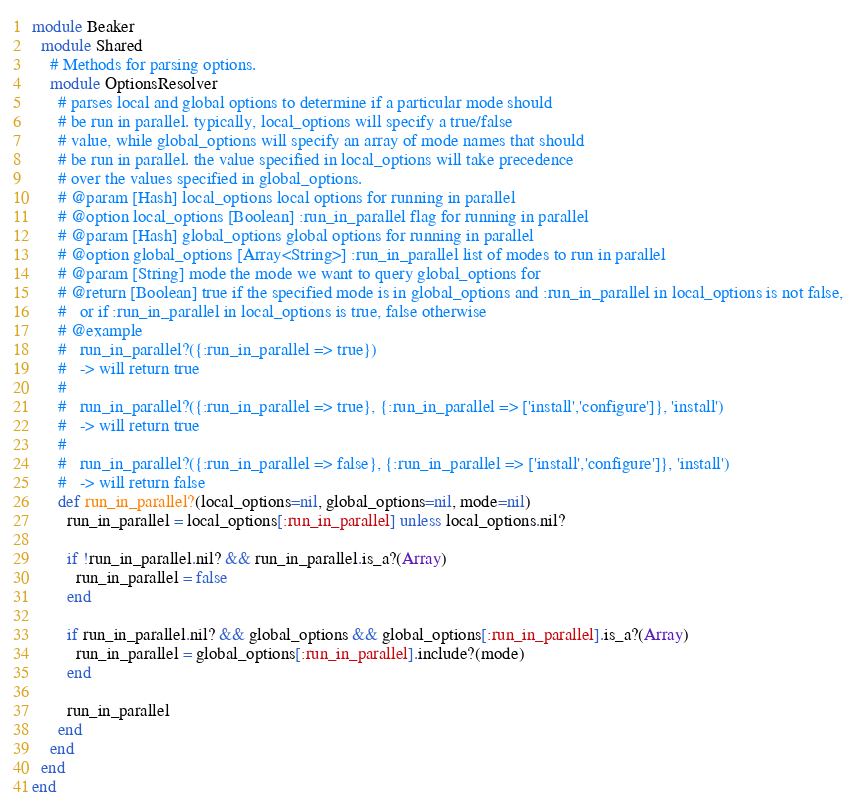<code> <loc_0><loc_0><loc_500><loc_500><_Ruby_>module Beaker
  module Shared
    # Methods for parsing options.
    module OptionsResolver
      # parses local and global options to determine if a particular mode should
      # be run in parallel. typically, local_options will specify a true/false
      # value, while global_options will specify an array of mode names that should
      # be run in parallel. the value specified in local_options will take precedence
      # over the values specified in global_options.
      # @param [Hash] local_options local options for running in parallel
      # @option local_options [Boolean] :run_in_parallel flag for running in parallel
      # @param [Hash] global_options global options for running in parallel
      # @option global_options [Array<String>] :run_in_parallel list of modes to run in parallel
      # @param [String] mode the mode we want to query global_options for
      # @return [Boolean] true if the specified mode is in global_options and :run_in_parallel in local_options is not false,
      #   or if :run_in_parallel in local_options is true, false otherwise
      # @example
      #   run_in_parallel?({:run_in_parallel => true})
      #   -> will return true
      #
      #   run_in_parallel?({:run_in_parallel => true}, {:run_in_parallel => ['install','configure']}, 'install')
      #   -> will return true
      #
      #   run_in_parallel?({:run_in_parallel => false}, {:run_in_parallel => ['install','configure']}, 'install')
      #   -> will return false
      def run_in_parallel?(local_options=nil, global_options=nil, mode=nil)
        run_in_parallel = local_options[:run_in_parallel] unless local_options.nil?

        if !run_in_parallel.nil? && run_in_parallel.is_a?(Array)
          run_in_parallel = false
        end

        if run_in_parallel.nil? && global_options && global_options[:run_in_parallel].is_a?(Array)
          run_in_parallel = global_options[:run_in_parallel].include?(mode)
        end

        run_in_parallel
      end
    end
  end
end
</code> 